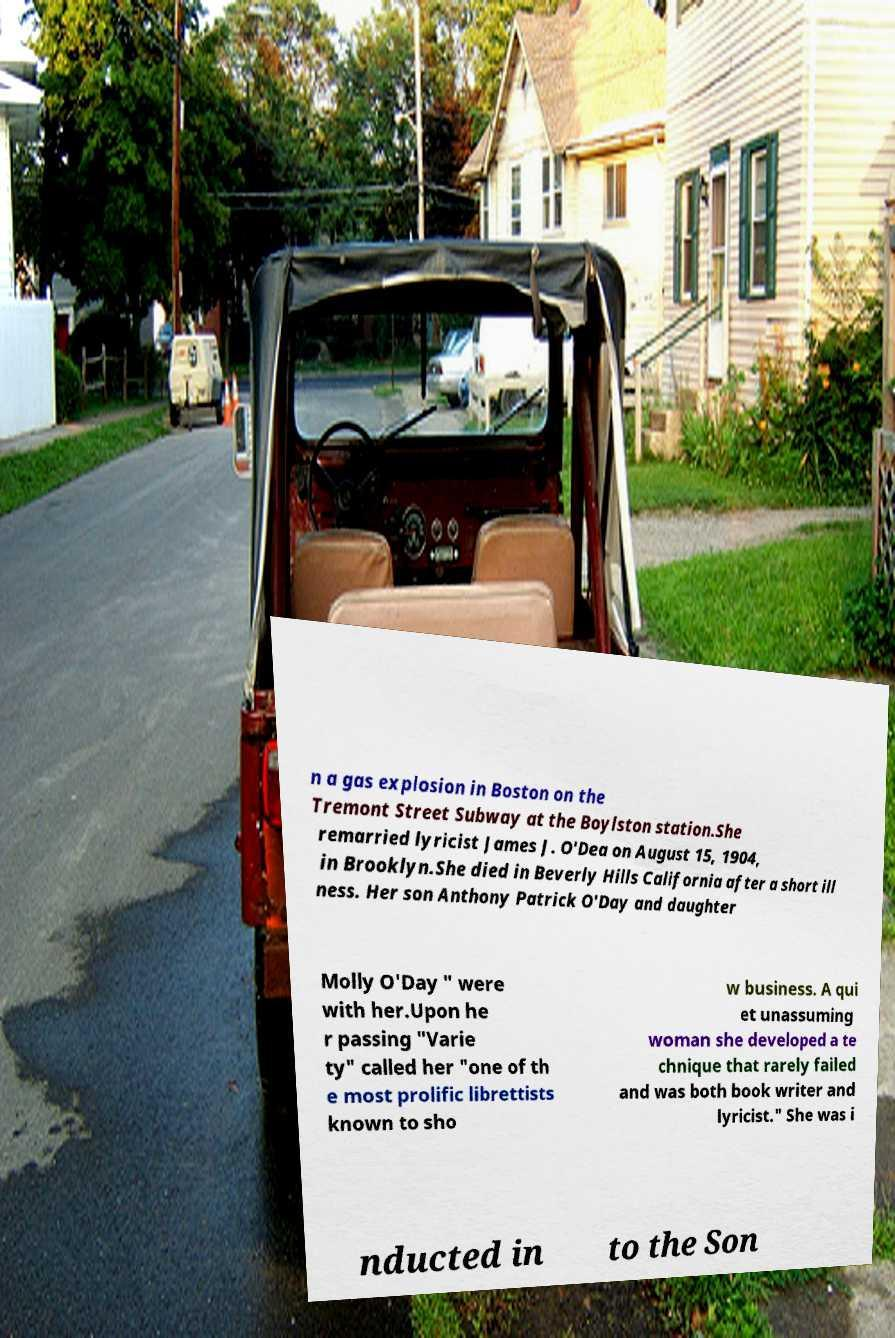What messages or text are displayed in this image? I need them in a readable, typed format. n a gas explosion in Boston on the Tremont Street Subway at the Boylston station.She remarried lyricist James J. O'Dea on August 15, 1904, in Brooklyn.She died in Beverly Hills California after a short ill ness. Her son Anthony Patrick O'Day and daughter Molly O'Day " were with her.Upon he r passing "Varie ty" called her "one of th e most prolific librettists known to sho w business. A qui et unassuming woman she developed a te chnique that rarely failed and was both book writer and lyricist." She was i nducted in to the Son 